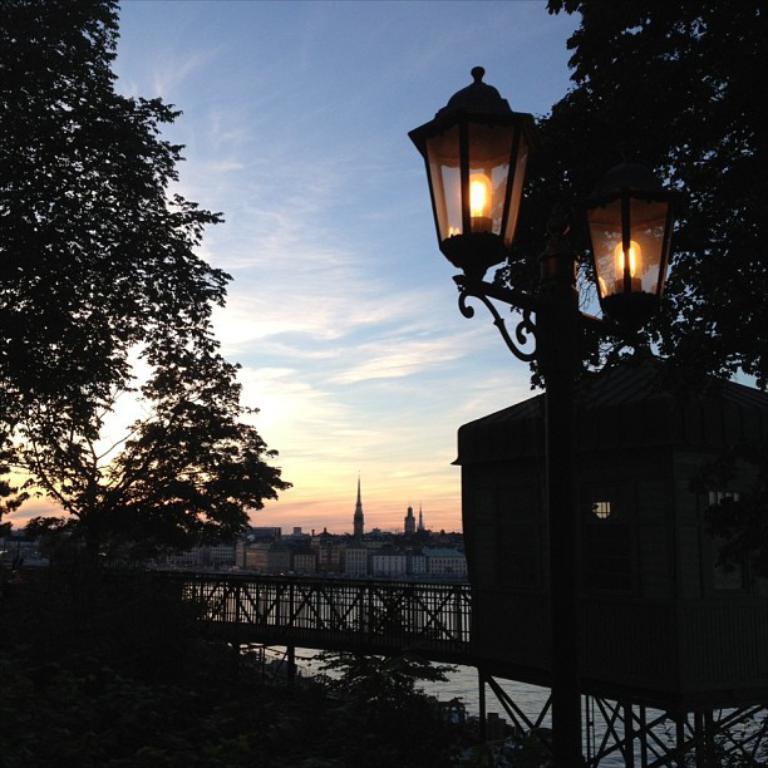Please provide a concise description of this image. In this image I can see the bridge, house and the lights. I can also see many trees and the water. In the background I can see many buildings, clouds and the sky. 